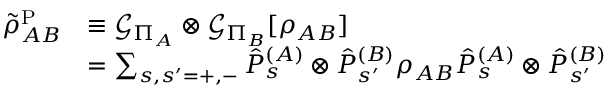Convert formula to latex. <formula><loc_0><loc_0><loc_500><loc_500>\begin{array} { r l } { \tilde { \rho } _ { A B } ^ { P } } & { \equiv \mathcal { G } _ { \Pi _ { A } } \otimes \mathcal { G } _ { \Pi _ { B } } [ \rho _ { A B } ] } \\ & { = \sum _ { s , s ^ { \prime } = + , - } \hat { P } _ { s } ^ { ( A ) } \otimes \hat { P } _ { s ^ { \prime } } ^ { ( B ) } \rho _ { A B } \hat { P } _ { s } ^ { ( A ) } \otimes \hat { P } _ { s ^ { \prime } } ^ { ( B ) } } \end{array}</formula> 